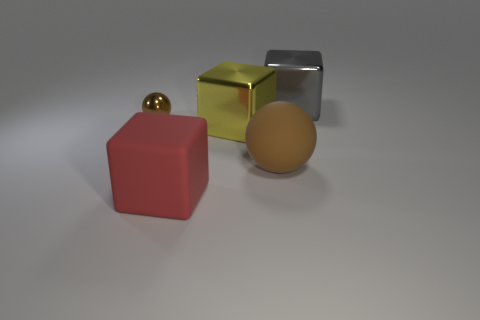Subtract all gray blocks. Subtract all purple spheres. How many blocks are left? 2 Add 1 red rubber spheres. How many objects exist? 6 Subtract all cubes. How many objects are left? 2 Subtract all gray metal cylinders. Subtract all red rubber things. How many objects are left? 4 Add 4 big cubes. How many big cubes are left? 7 Add 2 large brown things. How many large brown things exist? 3 Subtract 1 red cubes. How many objects are left? 4 